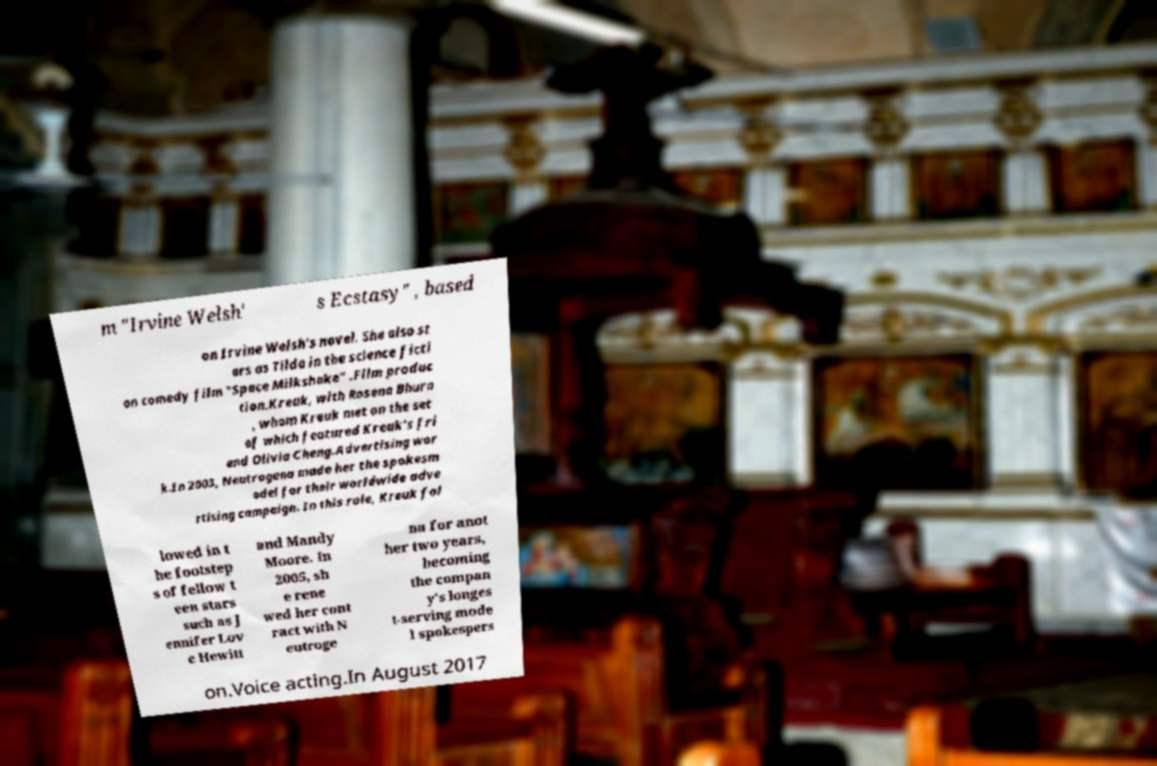For documentation purposes, I need the text within this image transcribed. Could you provide that? m "Irvine Welsh' s Ecstasy" , based on Irvine Welsh's novel. She also st ars as Tilda in the science ficti on comedy film "Space Milkshake" .Film produc tion.Kreuk, with Rosena Bhura , whom Kreuk met on the set of which featured Kreuk's fri end Olivia Cheng.Advertising wor k.In 2003, Neutrogena made her the spokesm odel for their worldwide adve rtising campaign. In this role, Kreuk fol lowed in t he footstep s of fellow t een stars such as J ennifer Lov e Hewitt and Mandy Moore. In 2005, sh e rene wed her cont ract with N eutroge na for anot her two years, becoming the compan y's longes t-serving mode l spokespers on.Voice acting.In August 2017 